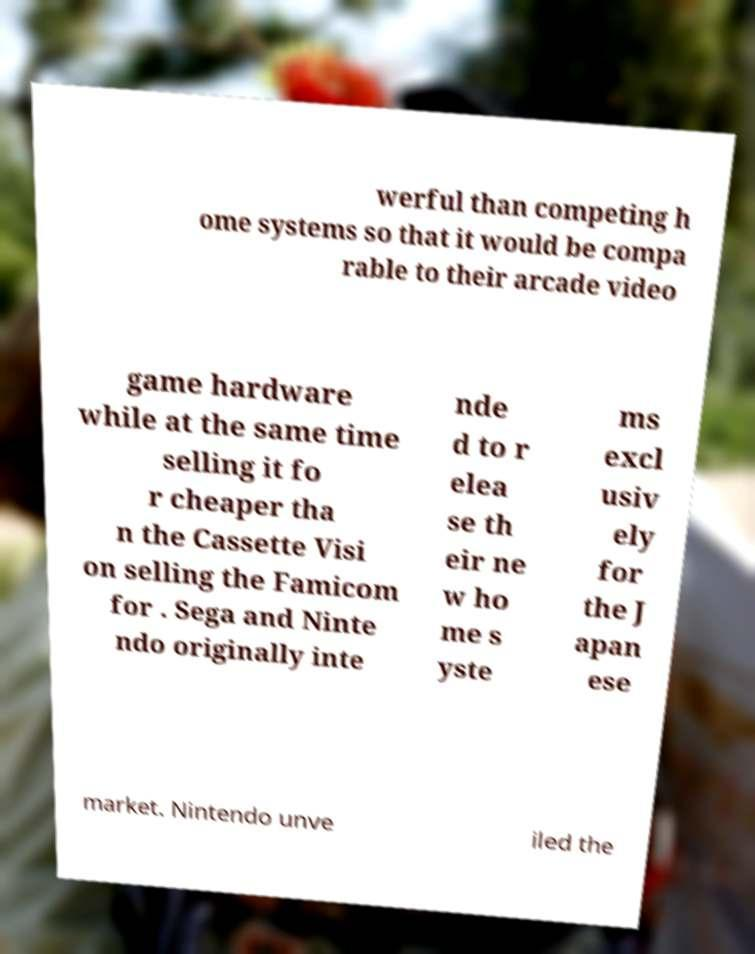For documentation purposes, I need the text within this image transcribed. Could you provide that? werful than competing h ome systems so that it would be compa rable to their arcade video game hardware while at the same time selling it fo r cheaper tha n the Cassette Visi on selling the Famicom for . Sega and Ninte ndo originally inte nde d to r elea se th eir ne w ho me s yste ms excl usiv ely for the J apan ese market. Nintendo unve iled the 